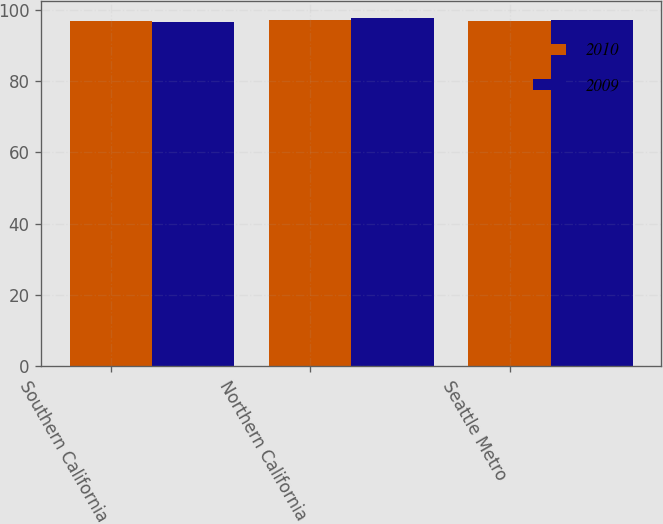Convert chart to OTSL. <chart><loc_0><loc_0><loc_500><loc_500><stacked_bar_chart><ecel><fcel>Southern California<fcel>Northern California<fcel>Seattle Metro<nl><fcel>2010<fcel>96.8<fcel>97.3<fcel>96.9<nl><fcel>2009<fcel>96.6<fcel>97.7<fcel>97.1<nl></chart> 